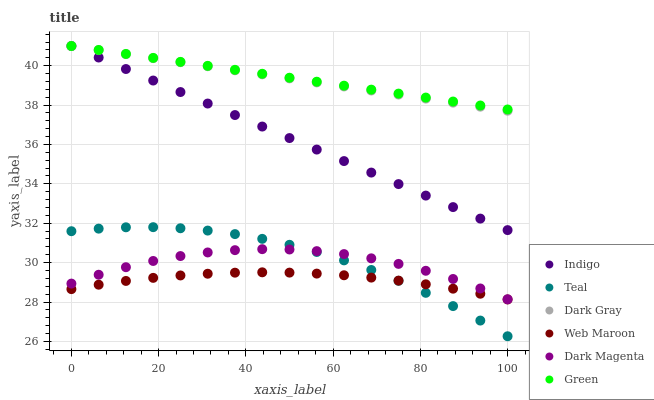Does Web Maroon have the minimum area under the curve?
Answer yes or no. Yes. Does Green have the maximum area under the curve?
Answer yes or no. Yes. Does Dark Magenta have the minimum area under the curve?
Answer yes or no. No. Does Dark Magenta have the maximum area under the curve?
Answer yes or no. No. Is Dark Gray the smoothest?
Answer yes or no. Yes. Is Dark Magenta the roughest?
Answer yes or no. Yes. Is Web Maroon the smoothest?
Answer yes or no. No. Is Web Maroon the roughest?
Answer yes or no. No. Does Teal have the lowest value?
Answer yes or no. Yes. Does Dark Magenta have the lowest value?
Answer yes or no. No. Does Green have the highest value?
Answer yes or no. Yes. Does Dark Magenta have the highest value?
Answer yes or no. No. Is Web Maroon less than Dark Gray?
Answer yes or no. Yes. Is Dark Gray greater than Dark Magenta?
Answer yes or no. Yes. Does Green intersect Indigo?
Answer yes or no. Yes. Is Green less than Indigo?
Answer yes or no. No. Is Green greater than Indigo?
Answer yes or no. No. Does Web Maroon intersect Dark Gray?
Answer yes or no. No. 